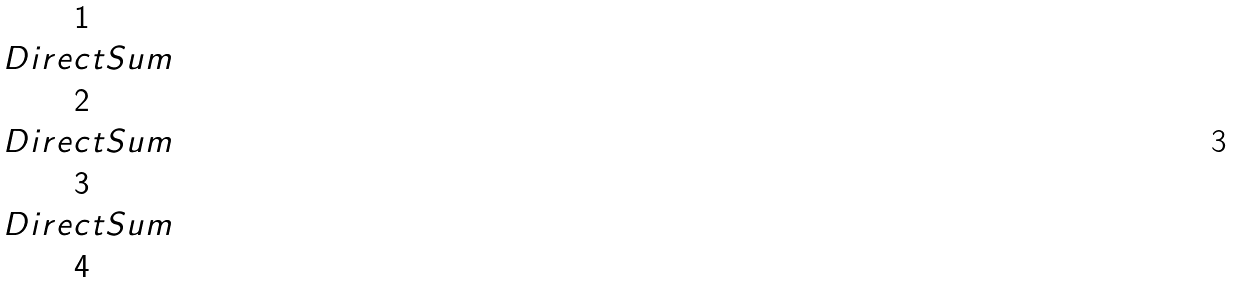Convert formula to latex. <formula><loc_0><loc_0><loc_500><loc_500>\begin{matrix} 1 \\ \ D i r e c t S u m \\ 2 \\ \ D i r e c t S u m \\ 3 \\ \ D i r e c t S u m \\ 4 \end{matrix}</formula> 